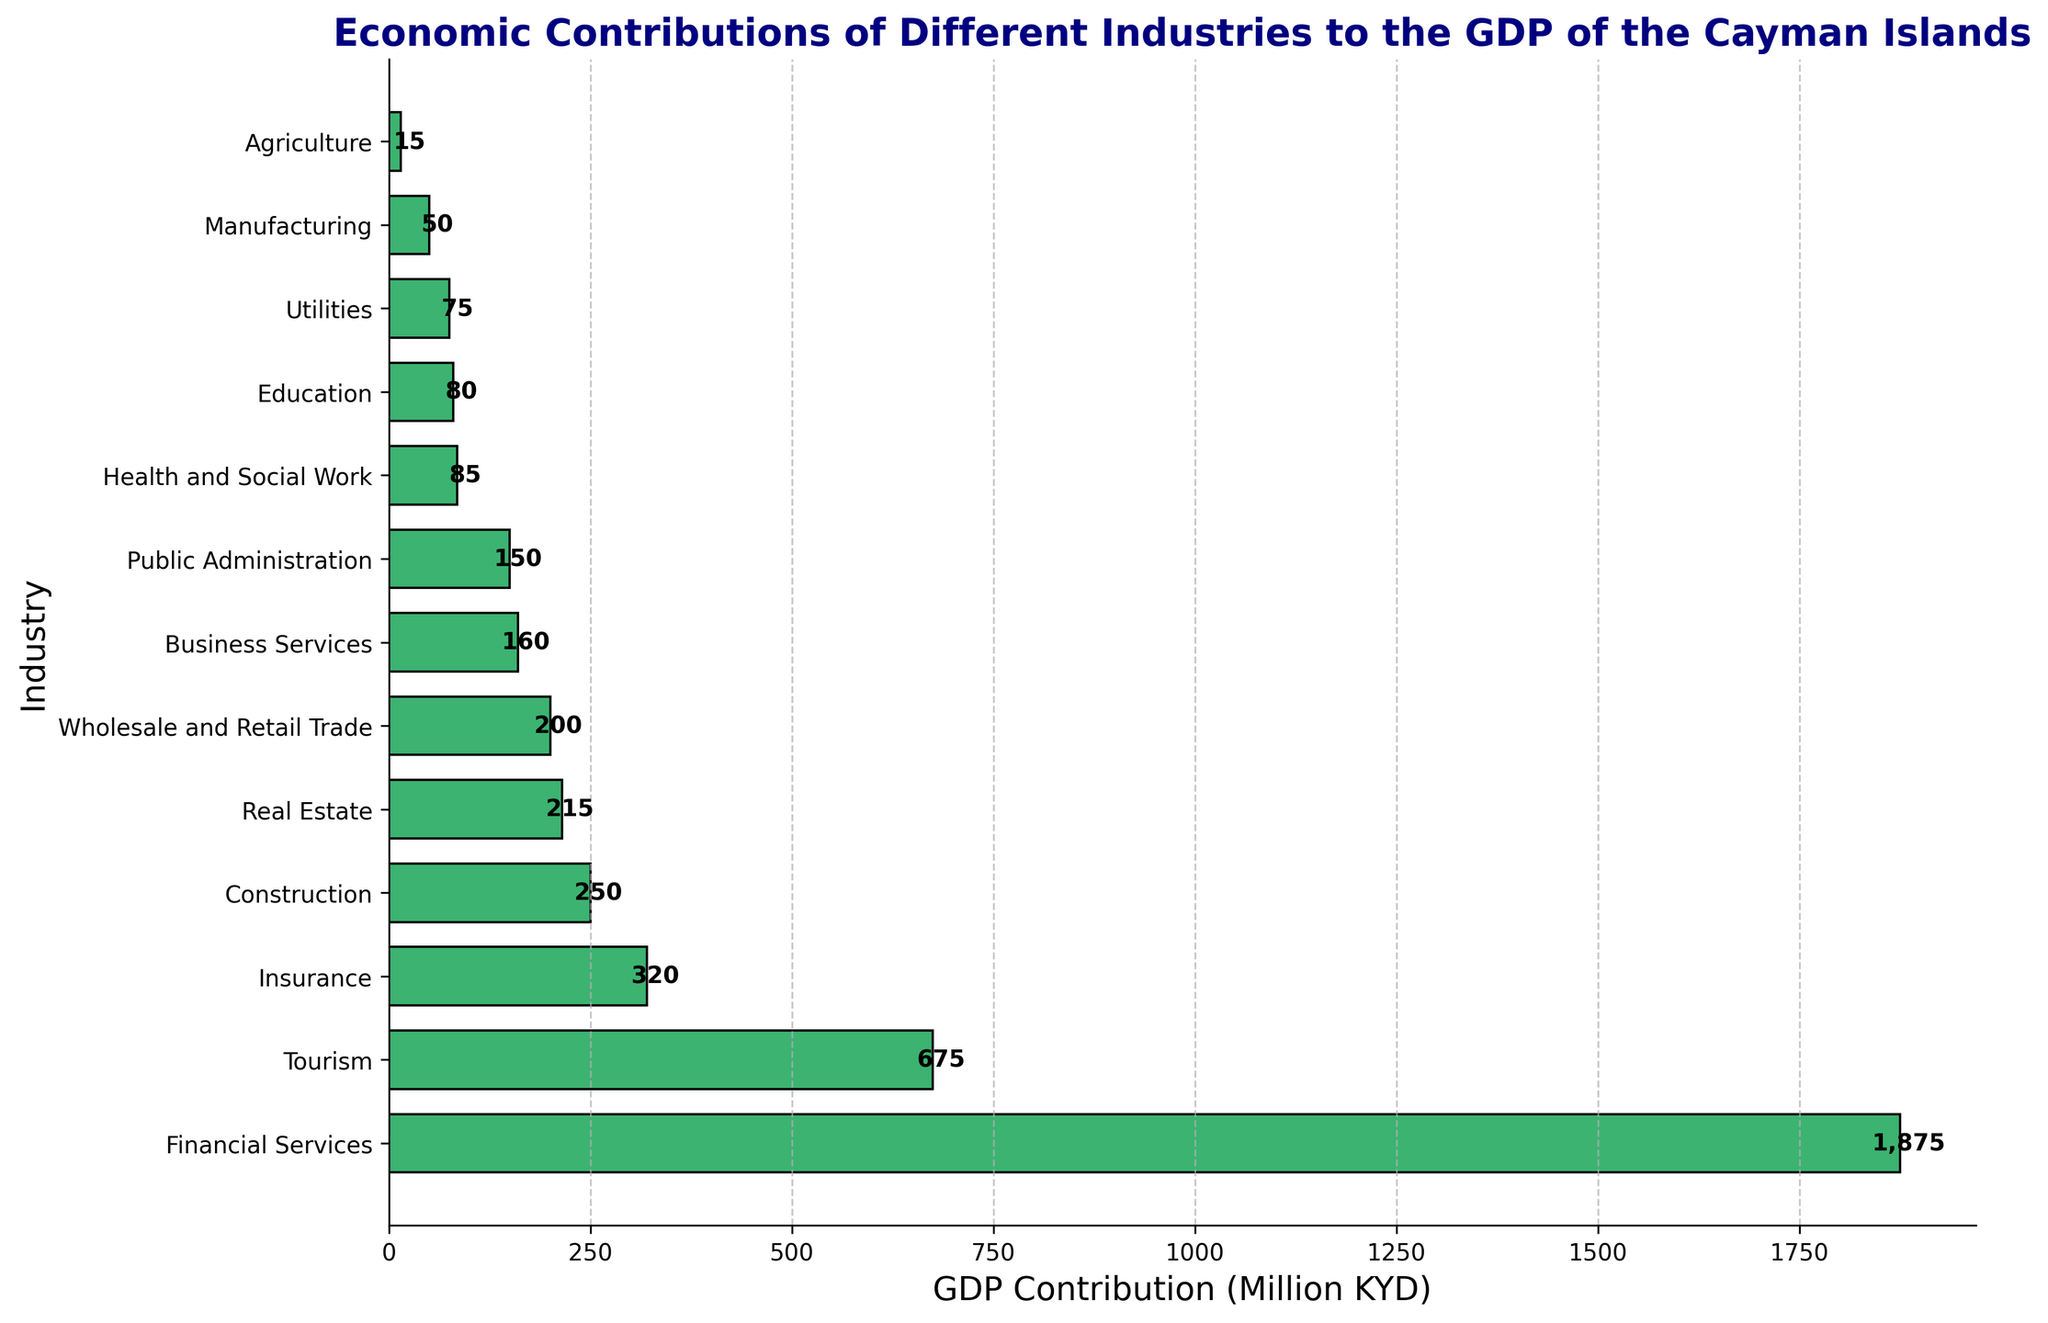Which industry has the highest GDP contribution? The bar with the longest length represents the industry with the highest GDP contribution. In this case, it is Financial Services.
Answer: Financial Services Which two industries have a combined GDP contribution equal to or more than Tourism? Tourism's contribution is 675 million KYD. We need to find two industries whose combined GDP contribution is equal to or greater than this amount. Insurance (320 million KYD) and Construction (250 million KYD) together sum to 570 million KYD, which is less than 675 million KYD. Adding Real Estate (215 million KYD) will reach 785 million KYD. Thus, Insurance and Real Estate together exceed the amount of Tourism.
Answer: Insurance and Real Estate What is the difference in GDP contribution between the Financial Services and Public Administration industries? Financial Services contributes 1875 million KYD, while Public Administration contributes 150 million KYD. The difference is calculated as 1875 - 150.
Answer: 1725 million KYD Which industries contribute less than 100 million KYD to the GDP? By looking at the bars with lengths less than 100 on the x-axis, we see that Health and Social Work (85 million KYD), Education (80 million KYD), Utilities (75 million KYD), Manufacturing (50 million KYD), and Agriculture (15 million KYD) contribute less than 100 million KYD.
Answer: Health and Social Work, Education, Utilities, Manufacturing, Agriculture What is the total GDP contribution of the top three industries combined? The top three industries are Financial Services (1875 million KYD), Tourism (675 million KYD), and Insurance (320 million KYD). Their combined contribution is 1875 + 675 + 320.
Answer: 2870 million KYD Which industry has a higher GDP contribution: Business Services or Education? Business Services has a GDP contribution of 160 million KYD, whereas Education has 80 million KYD. Clearly, Business Services contributes more than Education.
Answer: Business Services What is the median GDP contribution value of all listed industries? To find the median, list all values in ascending order: 15, 50, 75, 80, 85, 150, 160, 200, 215, 250, 320, 675, 1875. There are 13 values, so the median is the 7th value, which is 160 million KYD.
Answer: 160 million KYD 